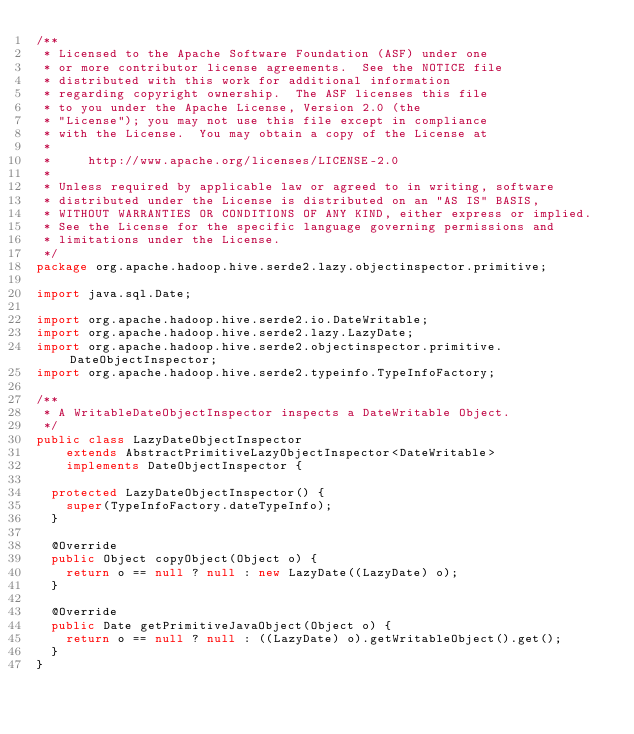<code> <loc_0><loc_0><loc_500><loc_500><_Java_>/**
 * Licensed to the Apache Software Foundation (ASF) under one
 * or more contributor license agreements.  See the NOTICE file
 * distributed with this work for additional information
 * regarding copyright ownership.  The ASF licenses this file
 * to you under the Apache License, Version 2.0 (the
 * "License"); you may not use this file except in compliance
 * with the License.  You may obtain a copy of the License at
 *
 *     http://www.apache.org/licenses/LICENSE-2.0
 *
 * Unless required by applicable law or agreed to in writing, software
 * distributed under the License is distributed on an "AS IS" BASIS,
 * WITHOUT WARRANTIES OR CONDITIONS OF ANY KIND, either express or implied.
 * See the License for the specific language governing permissions and
 * limitations under the License.
 */
package org.apache.hadoop.hive.serde2.lazy.objectinspector.primitive;

import java.sql.Date;

import org.apache.hadoop.hive.serde2.io.DateWritable;
import org.apache.hadoop.hive.serde2.lazy.LazyDate;
import org.apache.hadoop.hive.serde2.objectinspector.primitive.DateObjectInspector;
import org.apache.hadoop.hive.serde2.typeinfo.TypeInfoFactory;

/**
 * A WritableDateObjectInspector inspects a DateWritable Object.
 */
public class LazyDateObjectInspector
    extends AbstractPrimitiveLazyObjectInspector<DateWritable>
    implements DateObjectInspector {

  protected LazyDateObjectInspector() {
    super(TypeInfoFactory.dateTypeInfo);
  }

  @Override
  public Object copyObject(Object o) {
    return o == null ? null : new LazyDate((LazyDate) o);
  }

  @Override
  public Date getPrimitiveJavaObject(Object o) {
    return o == null ? null : ((LazyDate) o).getWritableObject().get();
  }
}
</code> 